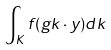Convert formula to latex. <formula><loc_0><loc_0><loc_500><loc_500>\int _ { K } f ( g k \cdot y ) d k</formula> 